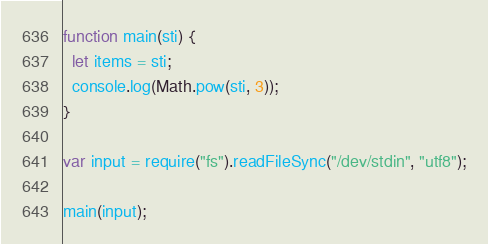Convert code to text. <code><loc_0><loc_0><loc_500><loc_500><_JavaScript_>function main(sti) {
  let items = sti;
  console.log(Math.pow(sti, 3));
}

var input = require("fs").readFileSync("/dev/stdin", "utf8");

main(input);

</code> 